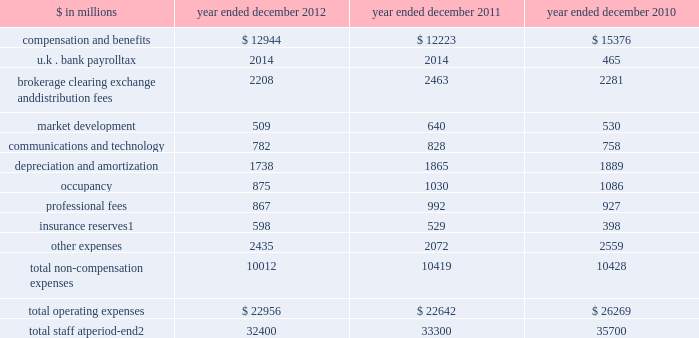Management 2019s discussion and analysis net interest income 2012 versus 2011 .
Net interest income on the consolidated statements of earnings was $ 3.88 billion for 2012 , 25% ( 25 % ) lower than 2011 .
The decrease compared with 2011 was primarily due to lower average yields on financial instruments owned , at fair value , and collateralized agreements .
2011 versus 2010 .
Net interest income on the consolidated statements of earnings was $ 5.19 billion for 2011 , 6% ( 6 % ) lower than 2010 .
The decrease compared with 2010 was primarily due to higher interest expense related to our long-term borrowings and higher dividend expense related to financial instruments sold , but not yet purchased , partially offset by an increase in interest income from higher yielding collateralized agreements .
Operating expenses our operating expenses are primarily influenced by compensation , headcount and levels of business activity .
Compensation and benefits includes salaries , discretionary compensation , amortization of equity awards and other items such as benefits .
Discretionary compensation is significantly impacted by , among other factors , the level of net revenues , overall financial performance , prevailing labor markets , business mix , the structure of our share-based compensation programs and the external environment .
In the context of more difficult economic and financial conditions , the firm launched an initiative during the second quarter of 2011 to identify areas where we can operate more efficiently and reduce our operating expenses .
During 2012 and 2011 , we announced targeted annual run rate compensation and non-compensation reductions of approximately $ 1.9 billion in aggregate .
The table below presents our operating expenses and total staff. .
Total staff at period-end 2 32400 33300 35700 1 .
Related revenues are included in 201cmarket making 201d on the consolidated statements of earnings .
Includes employees , consultants and temporary staff .
48 goldman sachs 2012 annual report .
What is the percentage change in the number of staff in 2012? 
Computations: ((32400 - 33300) / 33300)
Answer: -0.02703. 